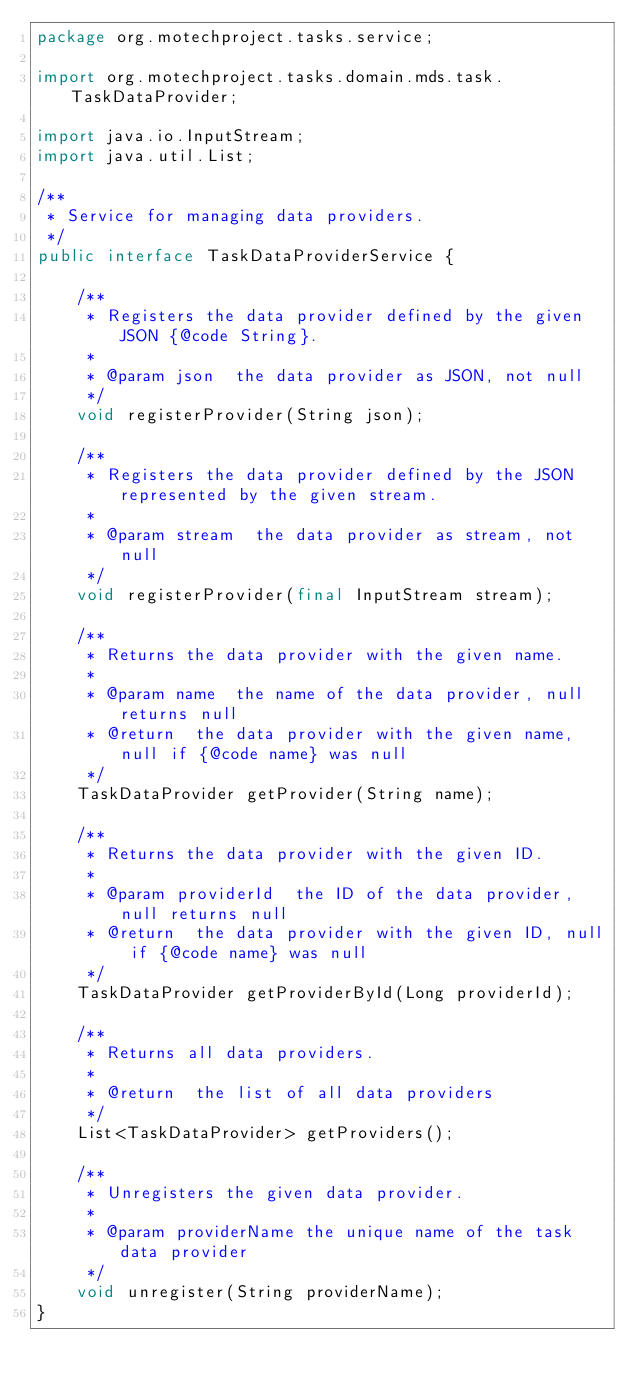Convert code to text. <code><loc_0><loc_0><loc_500><loc_500><_Java_>package org.motechproject.tasks.service;

import org.motechproject.tasks.domain.mds.task.TaskDataProvider;

import java.io.InputStream;
import java.util.List;

/**
 * Service for managing data providers.
 */
public interface TaskDataProviderService {

    /**
     * Registers the data provider defined by the given JSON {@code String}.
     *
     * @param json  the data provider as JSON, not null
     */
    void registerProvider(String json);

    /**
     * Registers the data provider defined by the JSON represented by the given stream.
     *
     * @param stream  the data provider as stream, not null
     */
    void registerProvider(final InputStream stream);

    /**
     * Returns the data provider with the given name.
     *
     * @param name  the name of the data provider, null returns null
     * @return  the data provider with the given name, null if {@code name} was null
     */
    TaskDataProvider getProvider(String name);

    /**
     * Returns the data provider with the given ID.
     *
     * @param providerId  the ID of the data provider, null returns null
     * @return  the data provider with the given ID, null if {@code name} was null
     */
    TaskDataProvider getProviderById(Long providerId);

    /**
     * Returns all data providers.
     *
     * @return  the list of all data providers
     */
    List<TaskDataProvider> getProviders();

    /**
     * Unregisters the given data provider.
     *
     * @param providerName the unique name of the task data provider
     */
    void unregister(String providerName);
}
</code> 